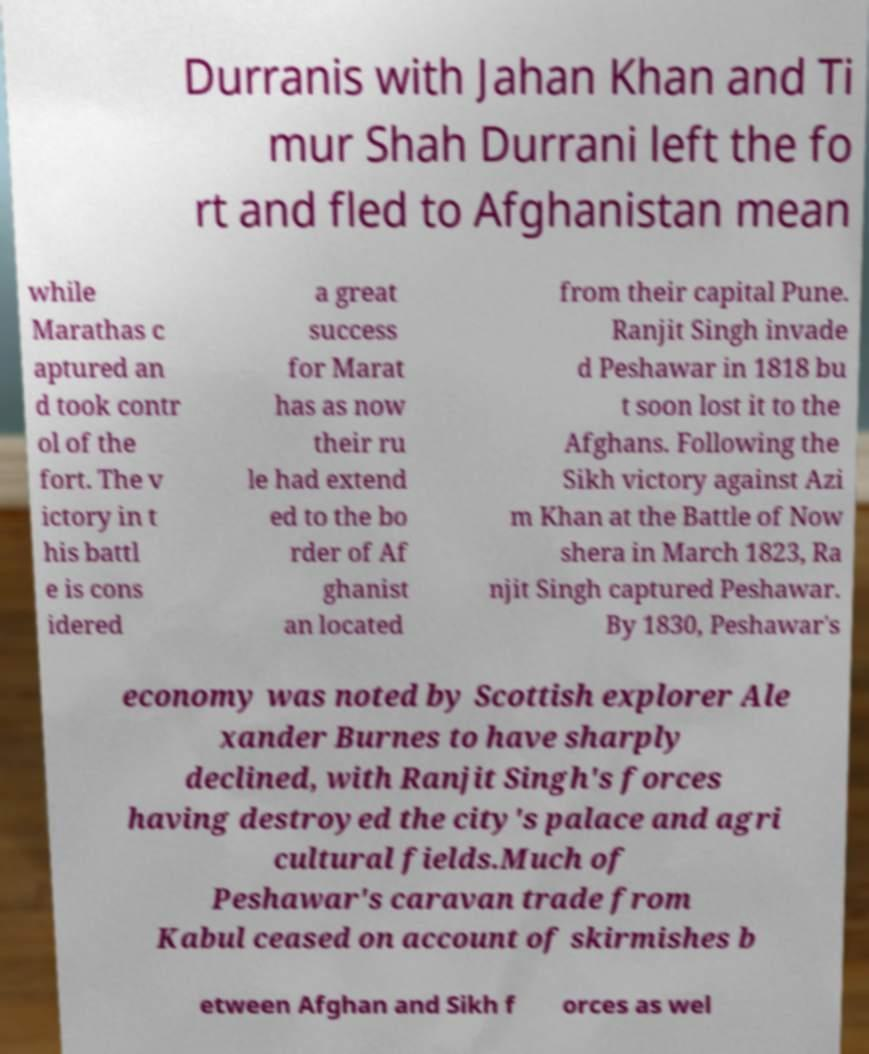There's text embedded in this image that I need extracted. Can you transcribe it verbatim? Durranis with Jahan Khan and Ti mur Shah Durrani left the fo rt and fled to Afghanistan mean while Marathas c aptured an d took contr ol of the fort. The v ictory in t his battl e is cons idered a great success for Marat has as now their ru le had extend ed to the bo rder of Af ghanist an located from their capital Pune. Ranjit Singh invade d Peshawar in 1818 bu t soon lost it to the Afghans. Following the Sikh victory against Azi m Khan at the Battle of Now shera in March 1823, Ra njit Singh captured Peshawar. By 1830, Peshawar's economy was noted by Scottish explorer Ale xander Burnes to have sharply declined, with Ranjit Singh's forces having destroyed the city's palace and agri cultural fields.Much of Peshawar's caravan trade from Kabul ceased on account of skirmishes b etween Afghan and Sikh f orces as wel 